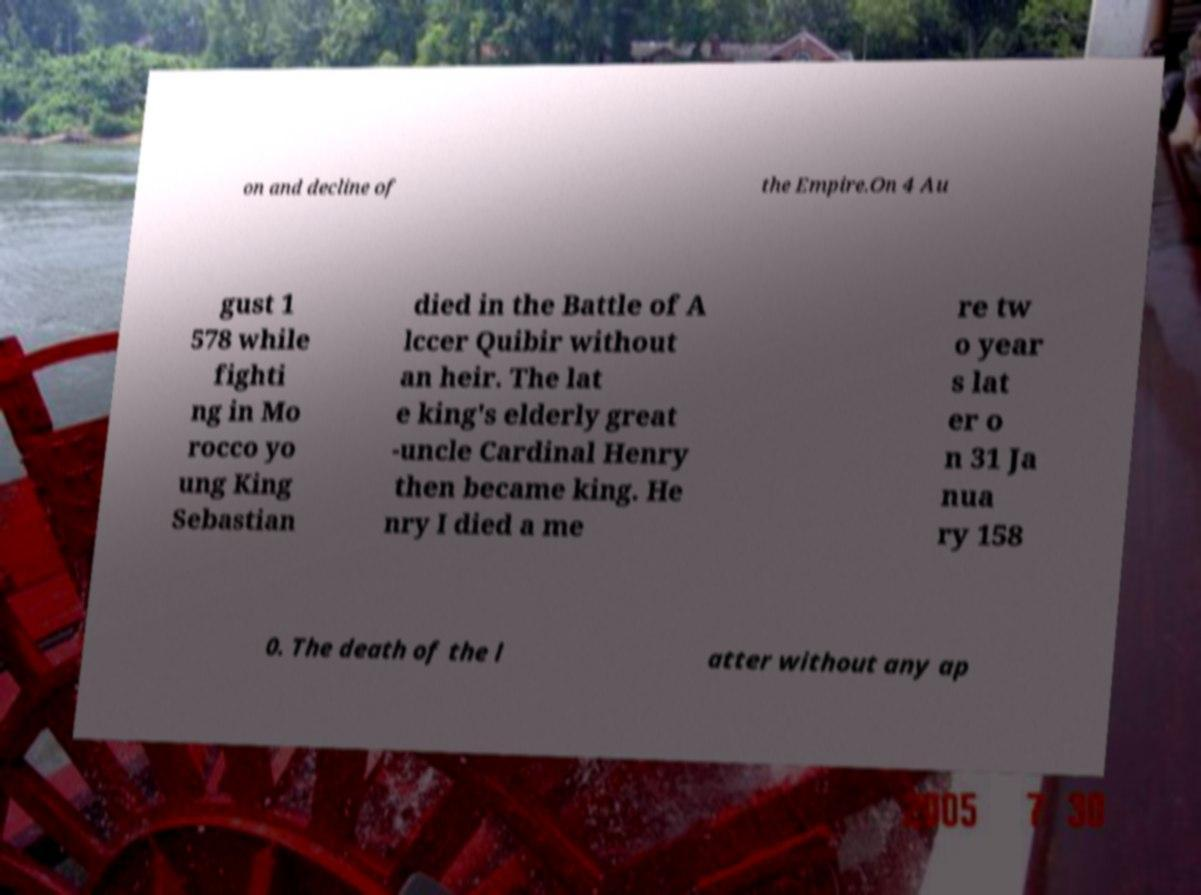I need the written content from this picture converted into text. Can you do that? on and decline of the Empire.On 4 Au gust 1 578 while fighti ng in Mo rocco yo ung King Sebastian died in the Battle of A lccer Quibir without an heir. The lat e king's elderly great -uncle Cardinal Henry then became king. He nry I died a me re tw o year s lat er o n 31 Ja nua ry 158 0. The death of the l atter without any ap 